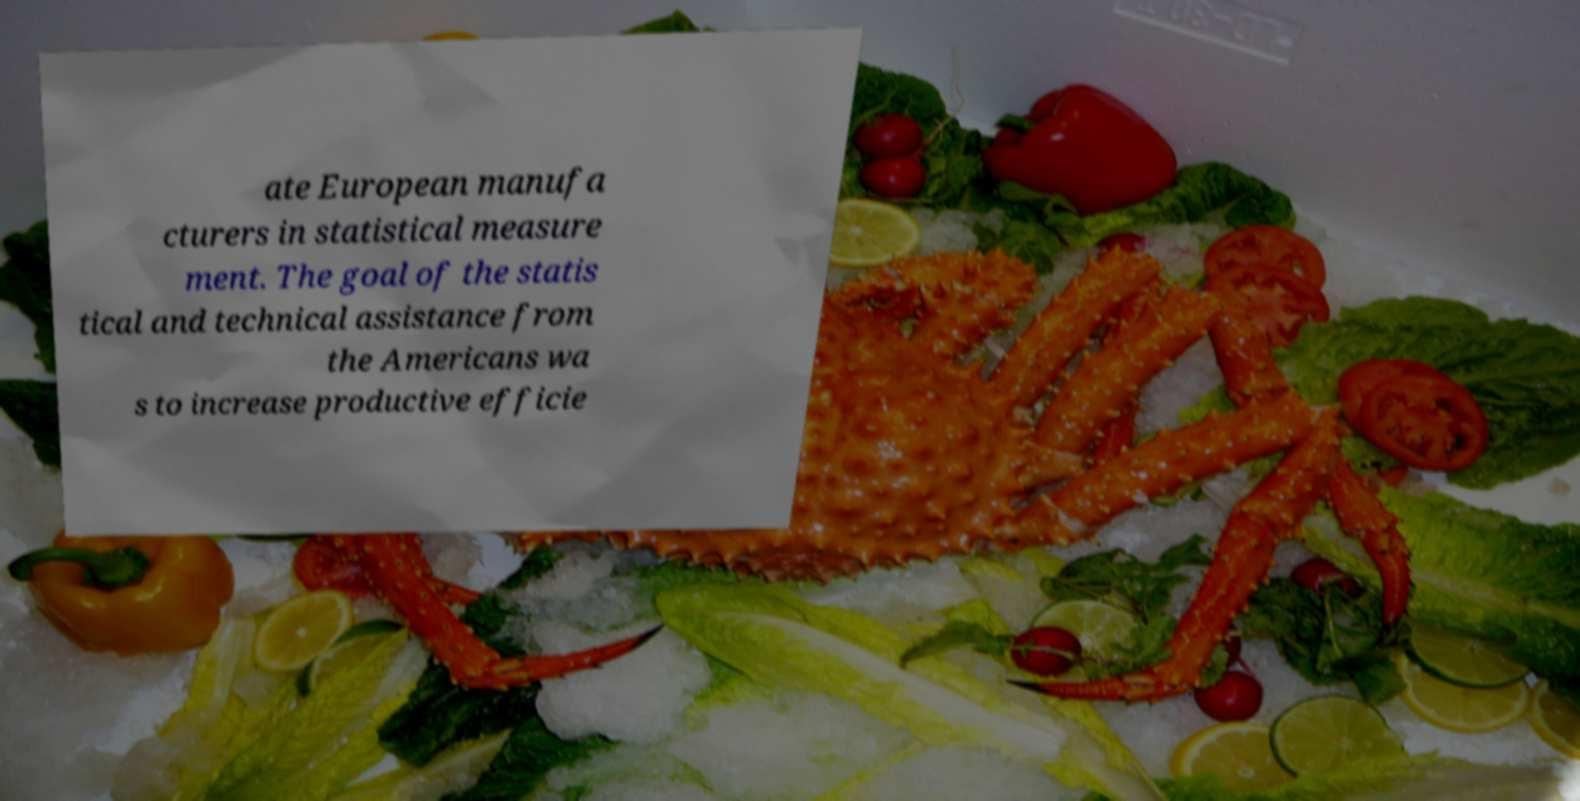There's text embedded in this image that I need extracted. Can you transcribe it verbatim? ate European manufa cturers in statistical measure ment. The goal of the statis tical and technical assistance from the Americans wa s to increase productive efficie 